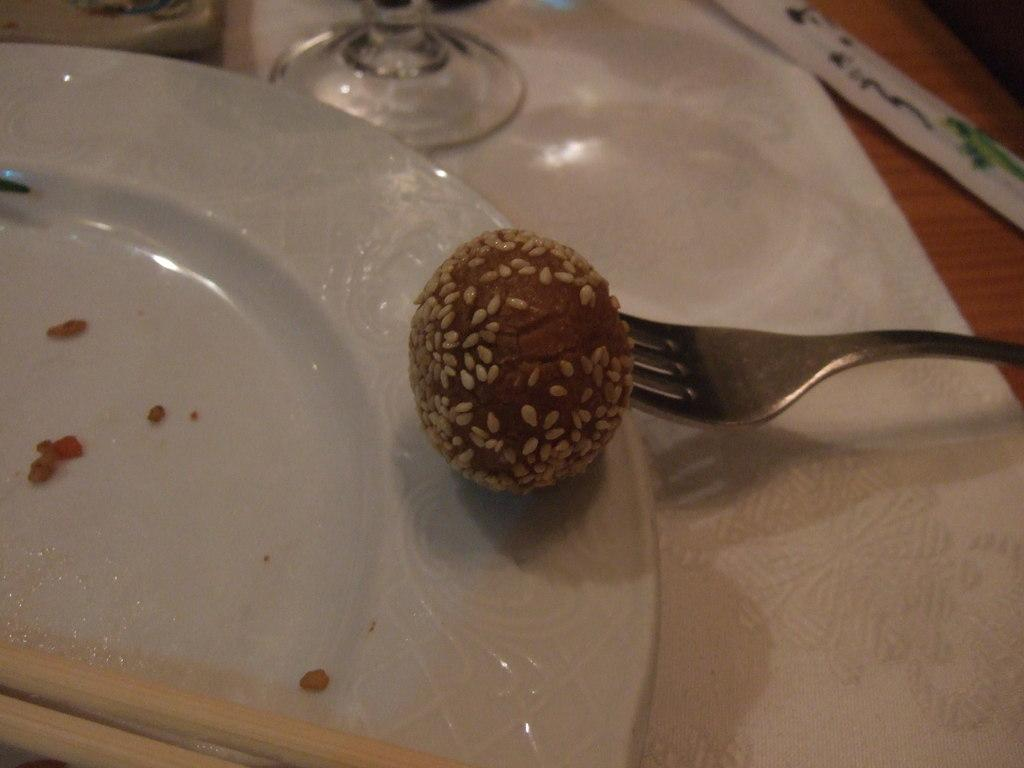What type of furniture is present in the image? There is a table in the image. What is covering the table? There is a cloth on the table. What is placed on the table? There is a plate, a fork, chopsticks, a glass, and other objects on the table. What type of food item is on the table? There is a food item on the table, and it has seeds on it. What type of meat is being served on the ship in the image? There is no ship or meat present in the image; it features a table with various items, including a food item with seeds. 